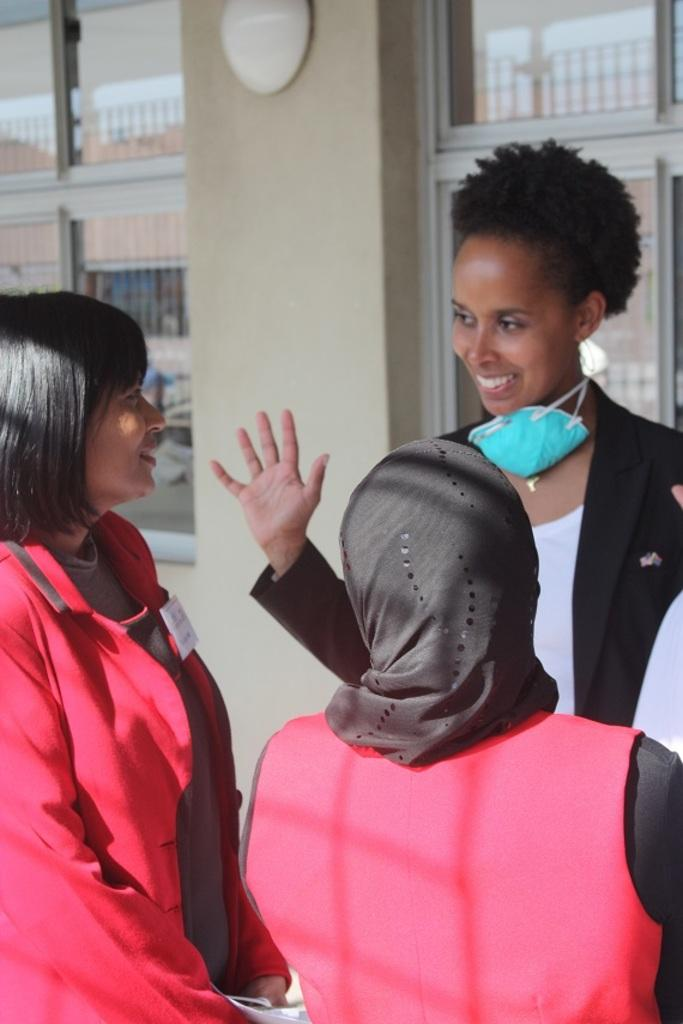What are the persons in the image doing? The persons in the image are standing in the center. What are the persons wearing? The persons are wearing coats. What can be seen in the background of the image? There are windows, a wall, glass, and an object in the background. What size reward is being given to the birds in the image? There are no birds or rewards present in the image. How do the birds fall from the wall in the image? There are no birds or walls in the image, so this scenario cannot be observed. 